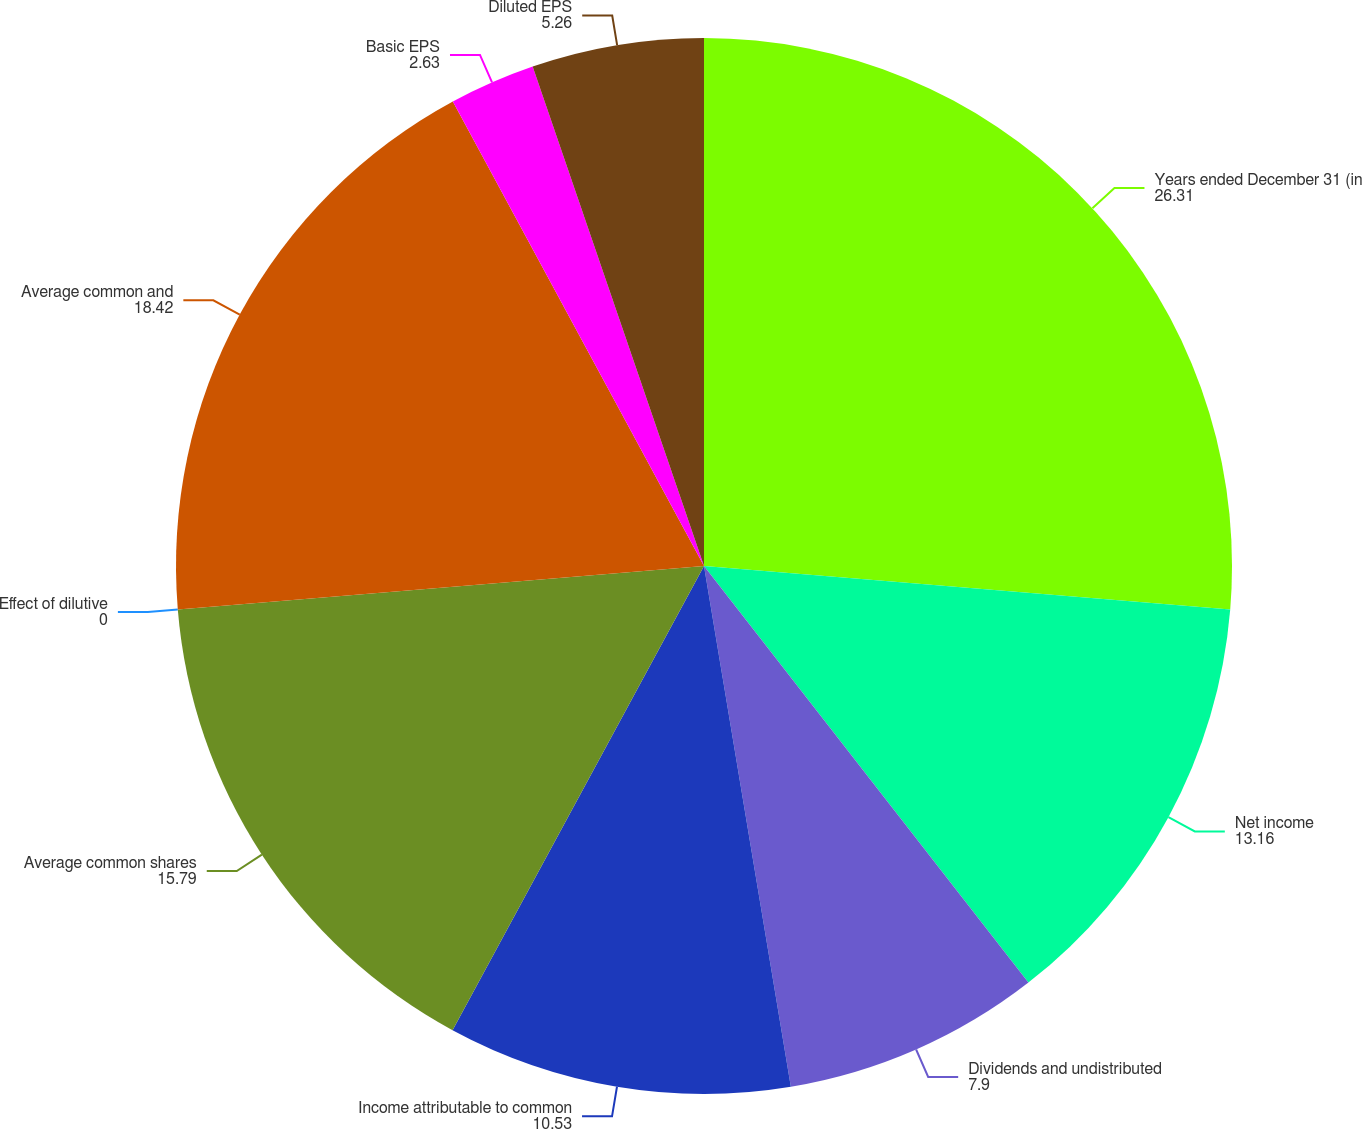Convert chart to OTSL. <chart><loc_0><loc_0><loc_500><loc_500><pie_chart><fcel>Years ended December 31 (in<fcel>Net income<fcel>Dividends and undistributed<fcel>Income attributable to common<fcel>Average common shares<fcel>Effect of dilutive<fcel>Average common and<fcel>Basic EPS<fcel>Diluted EPS<nl><fcel>26.31%<fcel>13.16%<fcel>7.9%<fcel>10.53%<fcel>15.79%<fcel>0.0%<fcel>18.42%<fcel>2.63%<fcel>5.26%<nl></chart> 